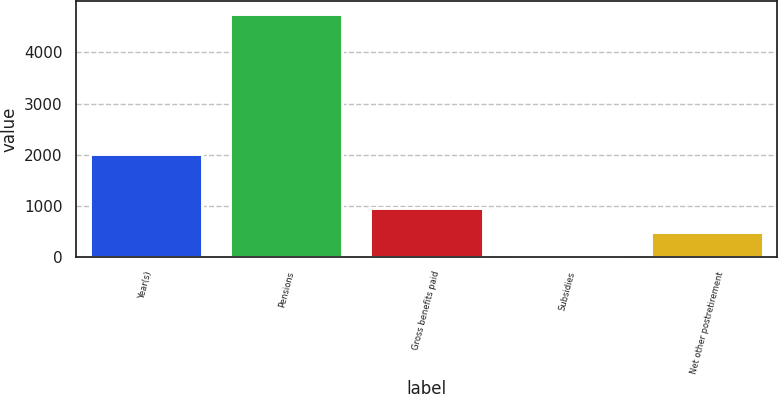Convert chart. <chart><loc_0><loc_0><loc_500><loc_500><bar_chart><fcel>Year(s)<fcel>Pensions<fcel>Gross benefits paid<fcel>Subsidies<fcel>Net other postretirement<nl><fcel>2018<fcel>4758<fcel>964.4<fcel>16<fcel>490.2<nl></chart> 